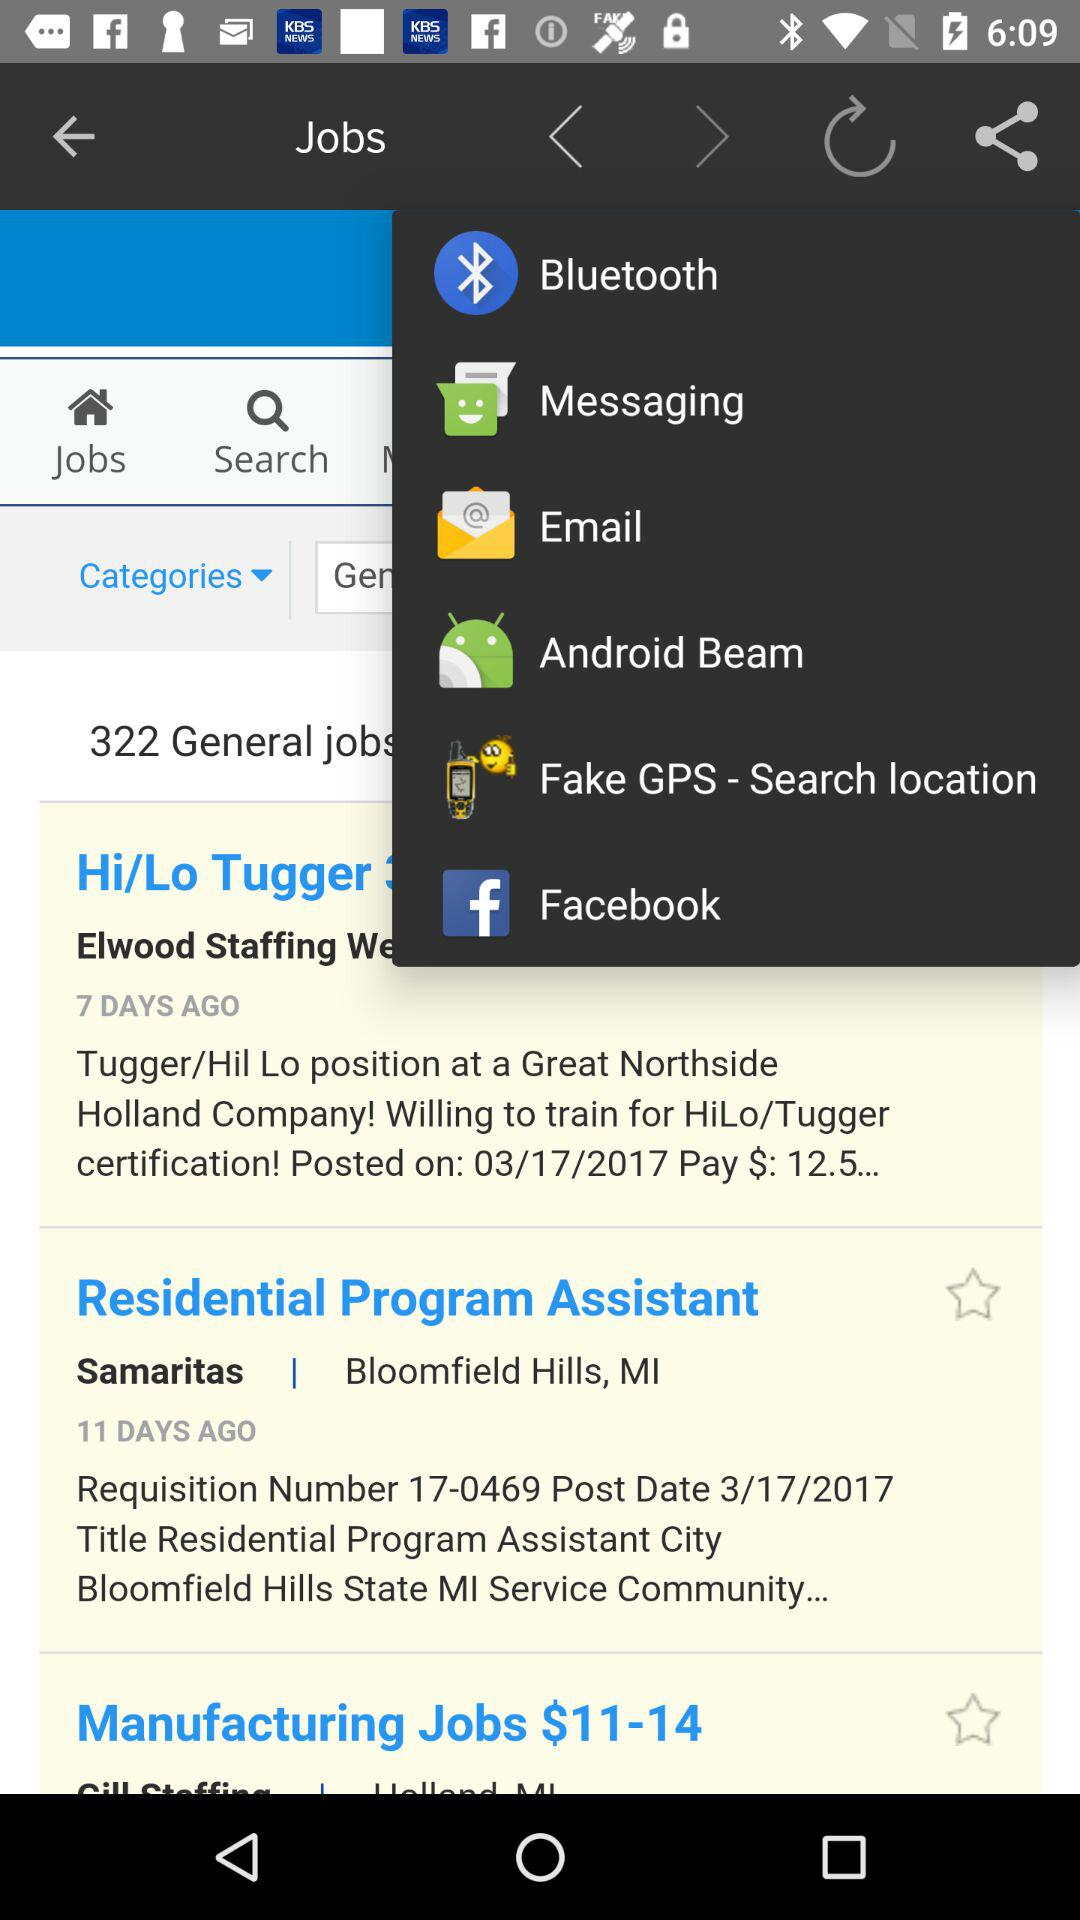What is the posted date for the Residential Program Assistant job? The posted date for the Residential Program Assistant job is March 17, 2017. 